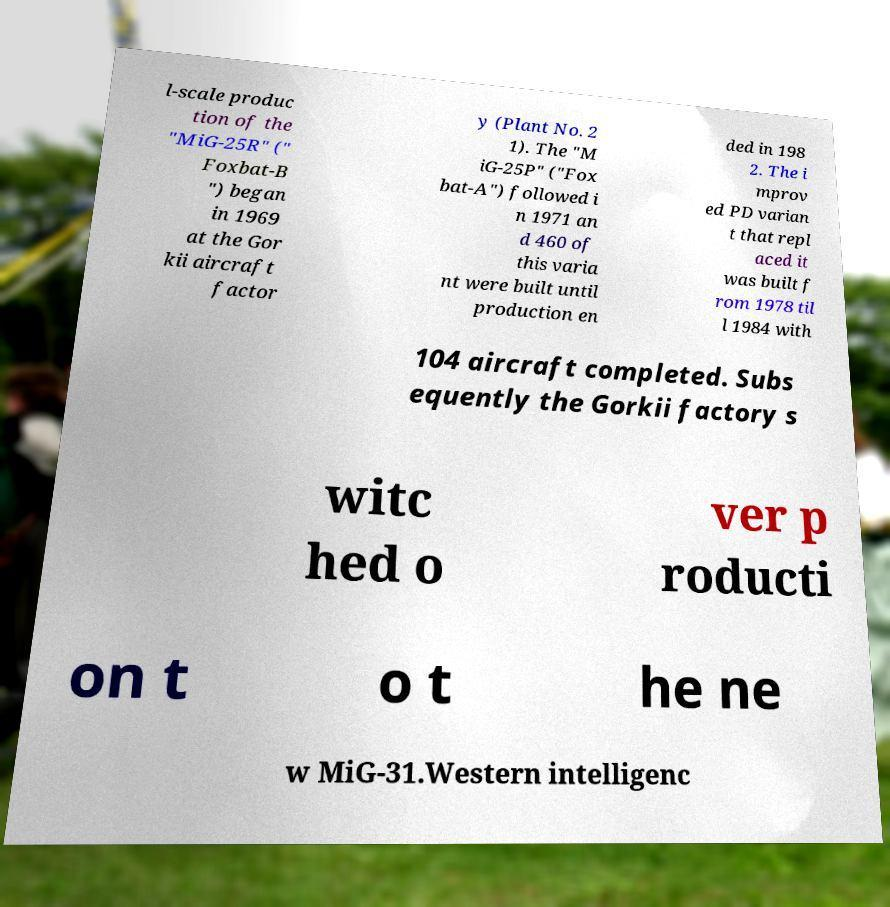I need the written content from this picture converted into text. Can you do that? l-scale produc tion of the "MiG-25R" (" Foxbat-B ") began in 1969 at the Gor kii aircraft factor y (Plant No. 2 1). The "M iG-25P" ("Fox bat-A") followed i n 1971 an d 460 of this varia nt were built until production en ded in 198 2. The i mprov ed PD varian t that repl aced it was built f rom 1978 til l 1984 with 104 aircraft completed. Subs equently the Gorkii factory s witc hed o ver p roducti on t o t he ne w MiG-31.Western intelligenc 